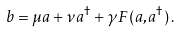<formula> <loc_0><loc_0><loc_500><loc_500>b = \mu a + \nu a ^ { \dagger } + \gamma F ( a , a ^ { \dagger } ) \, .</formula> 